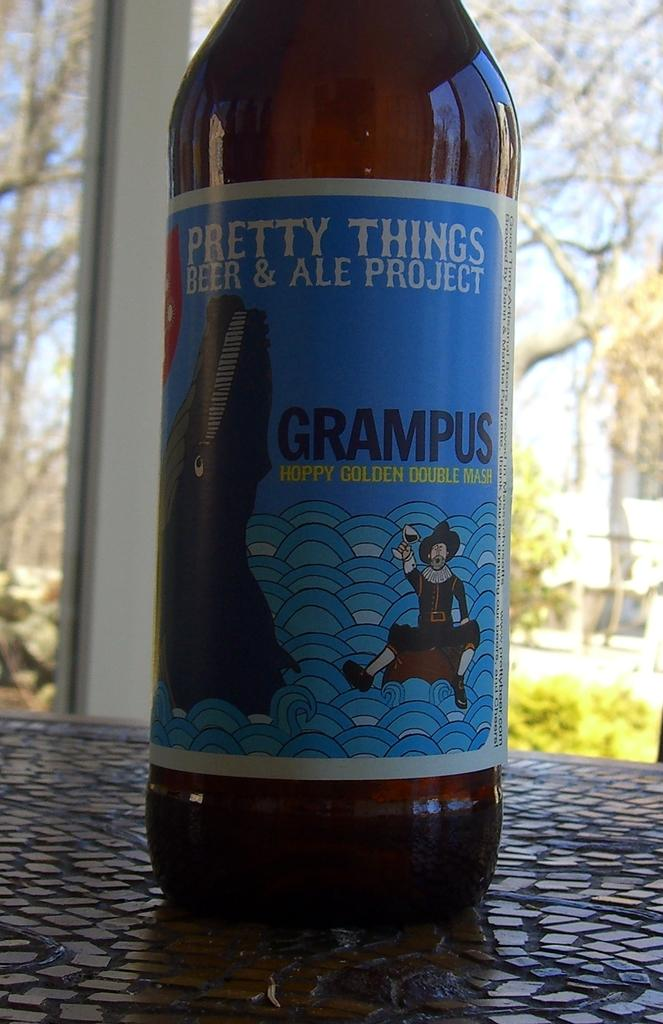<image>
Summarize the visual content of the image. A beer bottle with a blue art and the name Grampus on it. 